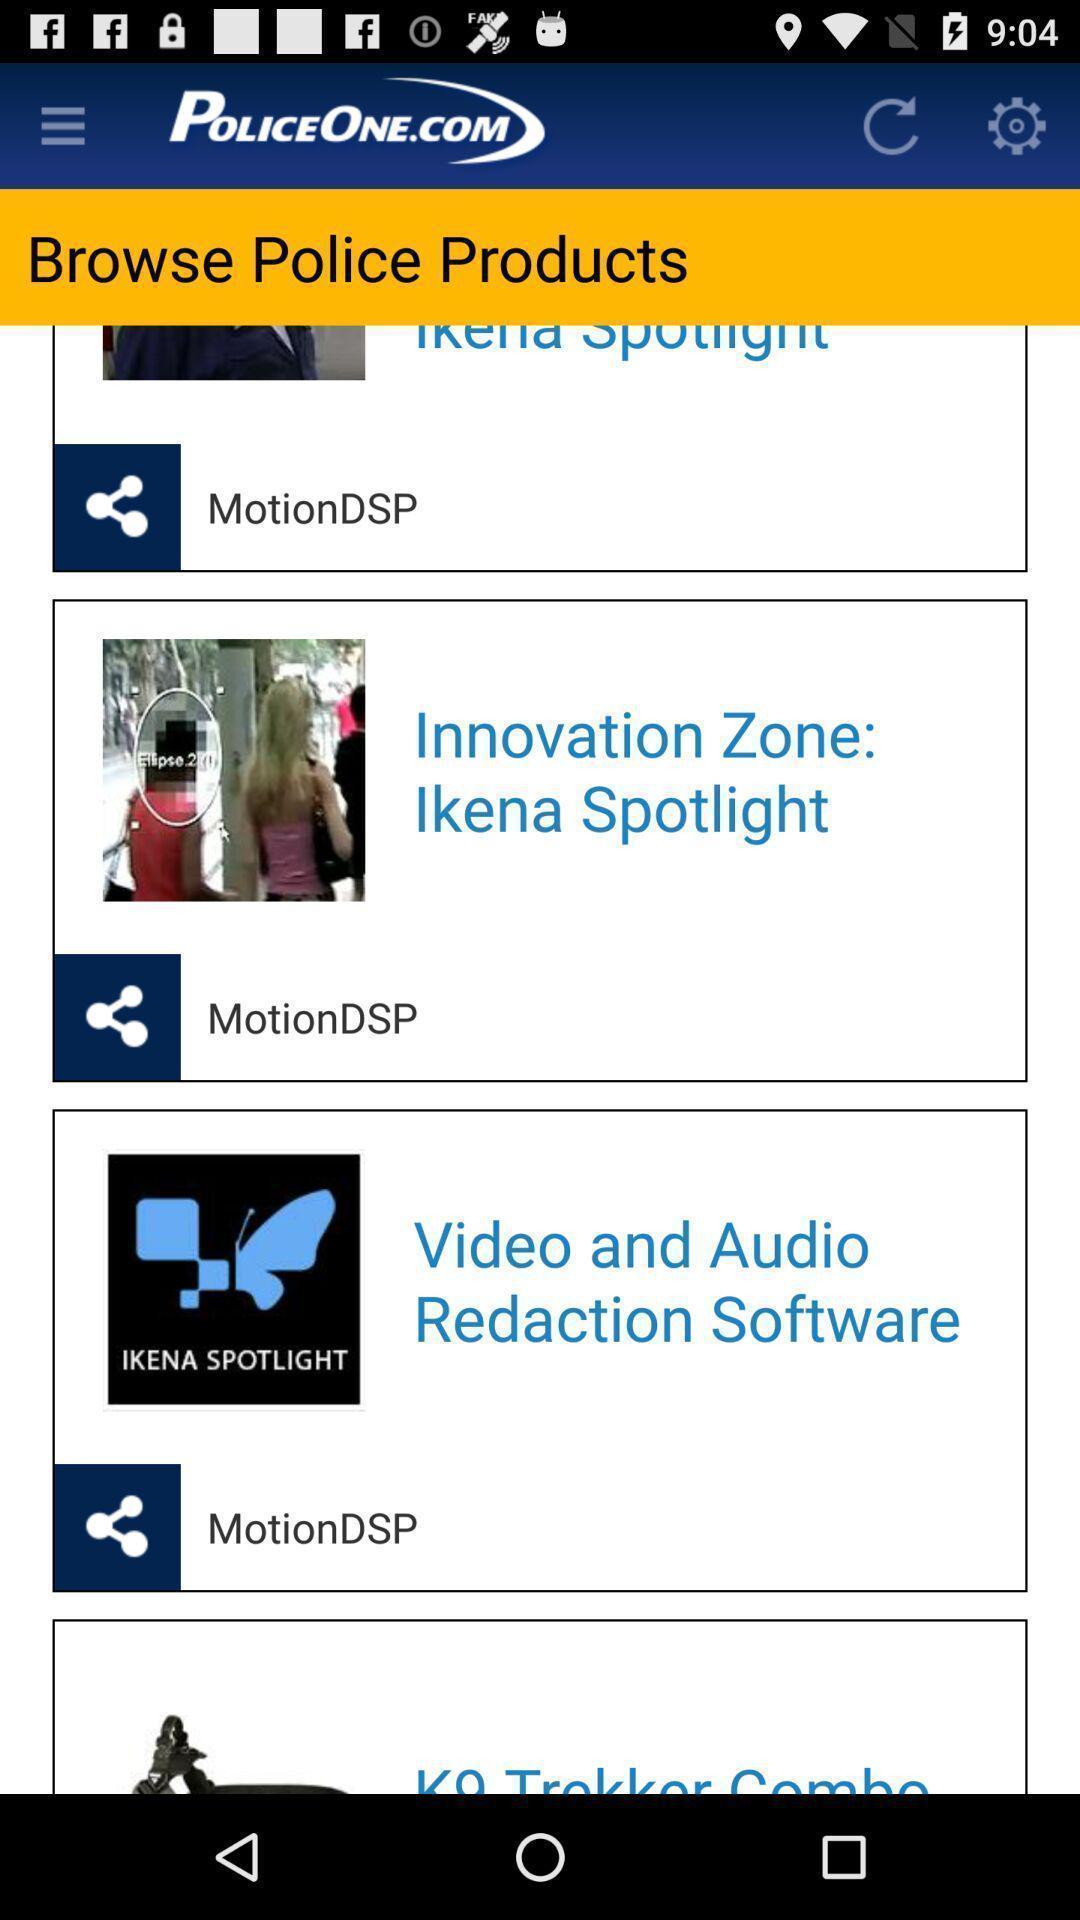Tell me what you see in this picture. Screen showing multiple topics. 